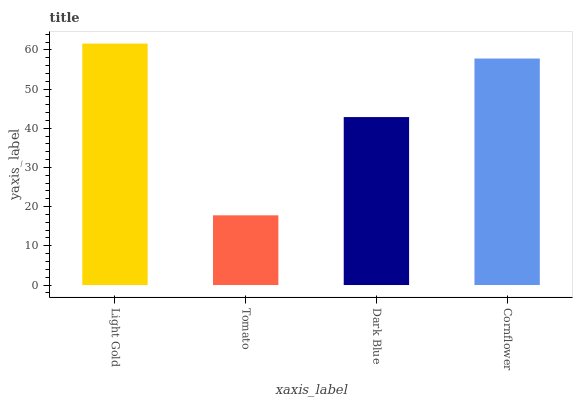Is Tomato the minimum?
Answer yes or no. Yes. Is Light Gold the maximum?
Answer yes or no. Yes. Is Dark Blue the minimum?
Answer yes or no. No. Is Dark Blue the maximum?
Answer yes or no. No. Is Dark Blue greater than Tomato?
Answer yes or no. Yes. Is Tomato less than Dark Blue?
Answer yes or no. Yes. Is Tomato greater than Dark Blue?
Answer yes or no. No. Is Dark Blue less than Tomato?
Answer yes or no. No. Is Cornflower the high median?
Answer yes or no. Yes. Is Dark Blue the low median?
Answer yes or no. Yes. Is Dark Blue the high median?
Answer yes or no. No. Is Light Gold the low median?
Answer yes or no. No. 